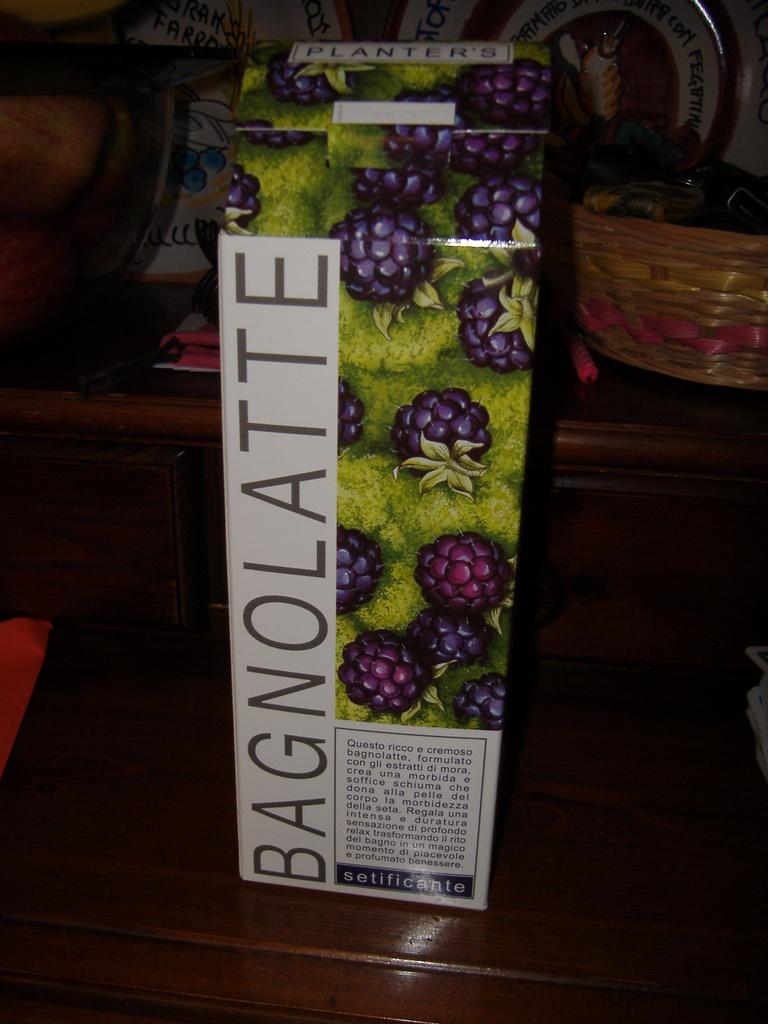What is the main object in the center of the image? There is a box in the center of the image. What can be seen on the box? There is text on the box. What objects are visible in the background of the image? There are baskets and plates in the background of the image. What type of furniture is at the bottom of the image? There is a wooden table at the bottom of the image. What type of treatment is being administered to the beast in the image? There is no beast present in the image, and therefore no treatment is being administered. 